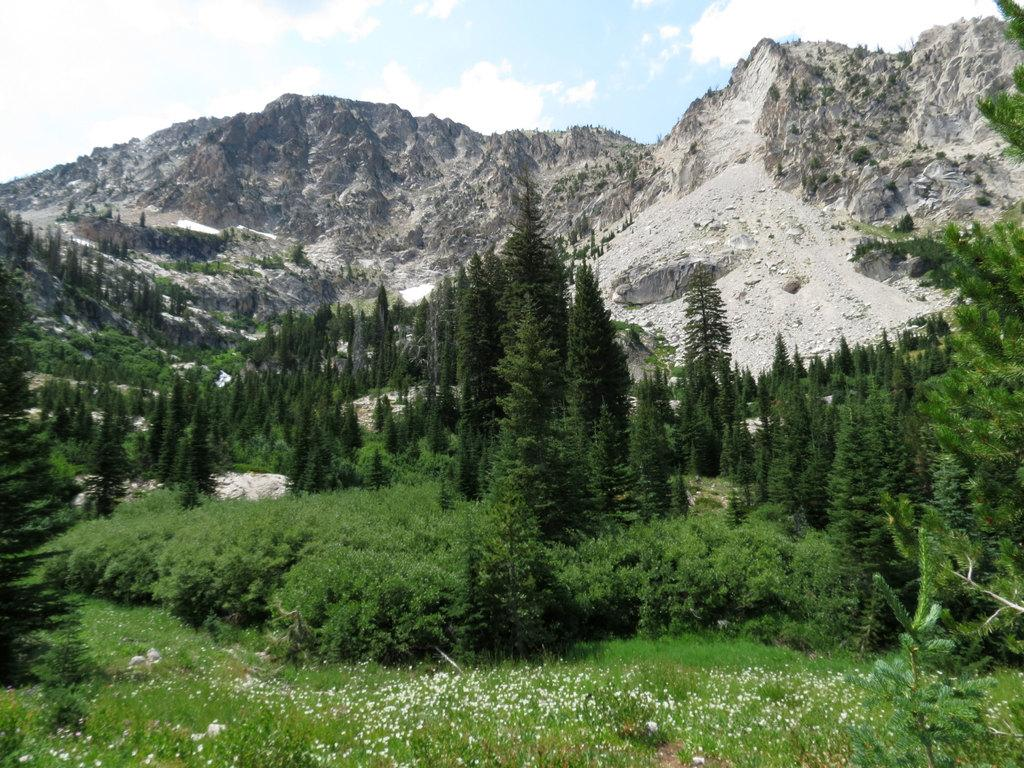What types of vegetation can be seen in the foreground of the image? There are plants and trees in the foreground of the image. What can be found in the center of the image? There are trees, shrubs, and mountains in the center of the image. What is visible at the top of the image? The sky is visible at the top of the image. What type of door can be seen in the image? There is no door present in the image. What is the thing that the plants and trees are doing in the image? The plants and trees are not performing any actions in the image; they are simply present. 